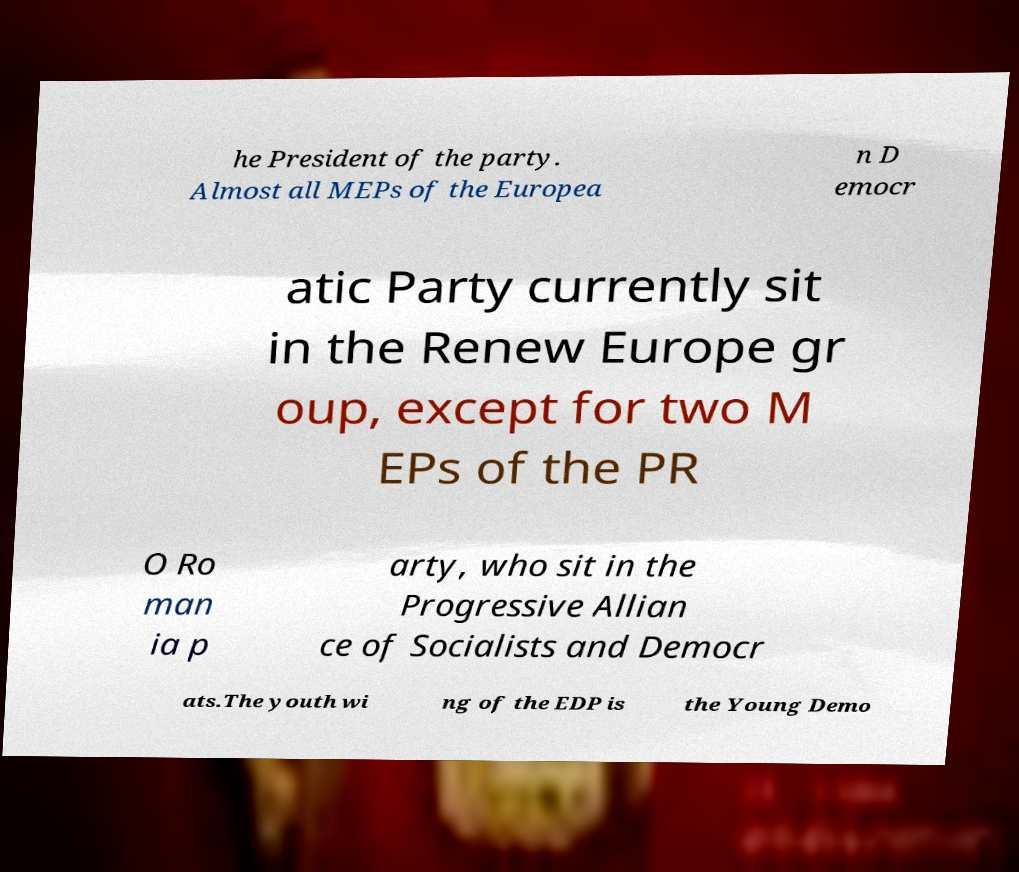Please identify and transcribe the text found in this image. he President of the party. Almost all MEPs of the Europea n D emocr atic Party currently sit in the Renew Europe gr oup, except for two M EPs of the PR O Ro man ia p arty, who sit in the Progressive Allian ce of Socialists and Democr ats.The youth wi ng of the EDP is the Young Demo 